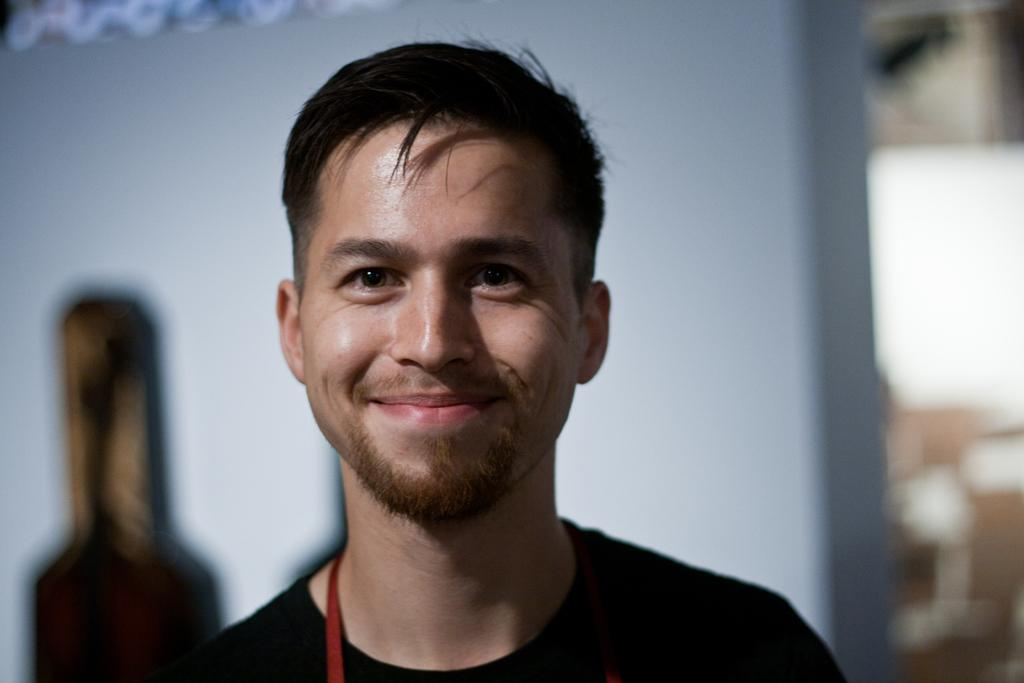What is the main subject of the image? The main subject of the image is a man. What is the man wearing in the image? The man is wearing a black t-shirt in the image. What is the man's facial expression in the image? The man is smiling in the image. What can be seen in the background of the image? There is a wall in the background of the image. What type of basin is the scarecrow holding in the image? There is no scarecrow or basin present in the image; it features a man wearing a black t-shirt and smiling. 